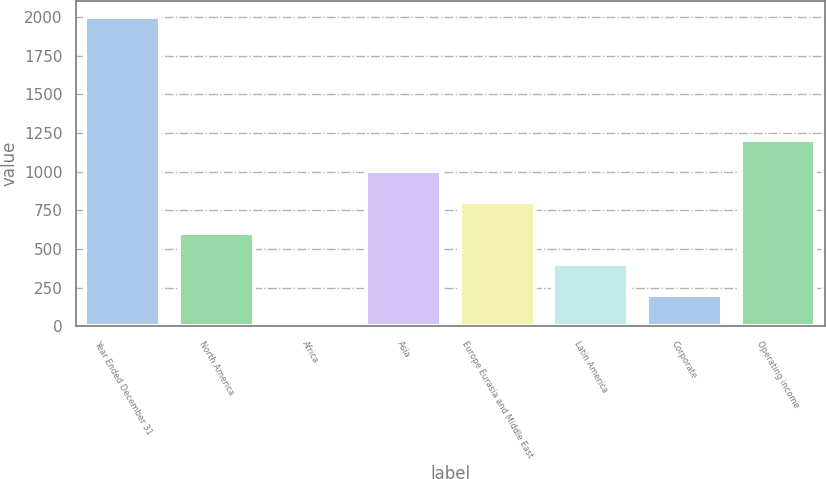Convert chart. <chart><loc_0><loc_0><loc_500><loc_500><bar_chart><fcel>Year Ended December 31<fcel>North America<fcel>Africa<fcel>Asia<fcel>Europe Eurasia and Middle East<fcel>Latin America<fcel>Corporate<fcel>Operating income<nl><fcel>2002<fcel>603.47<fcel>4.1<fcel>1003.05<fcel>803.26<fcel>403.68<fcel>203.89<fcel>1202.84<nl></chart> 